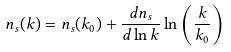Convert formula to latex. <formula><loc_0><loc_0><loc_500><loc_500>n _ { s } ( k ) = n _ { s } ( k _ { 0 } ) + \frac { d n _ { s } } { d \ln k } \ln \left ( \frac { k } { k _ { 0 } } \right )</formula> 